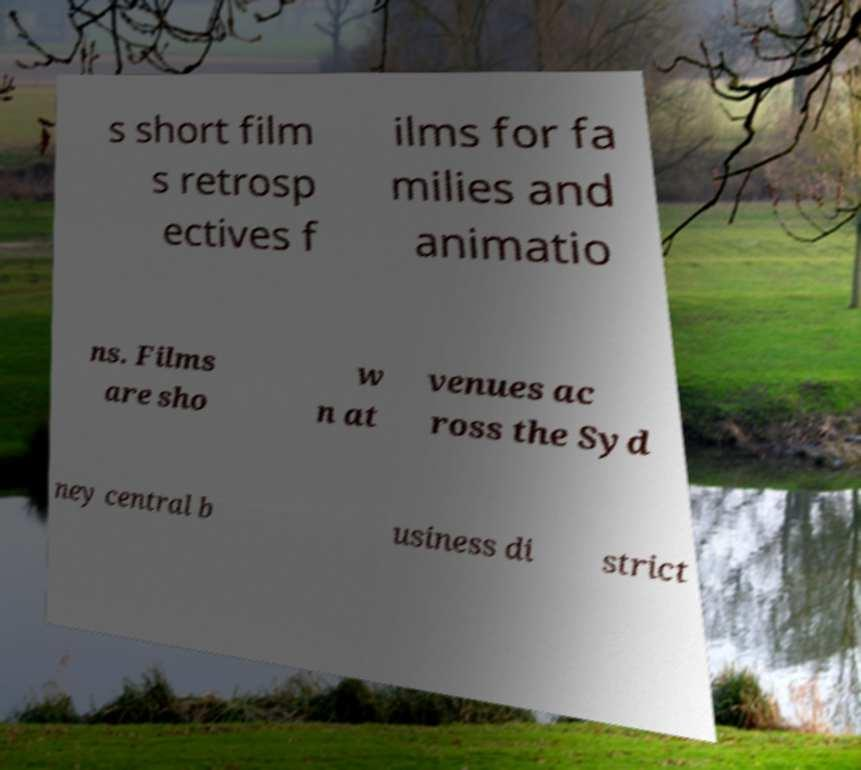Can you accurately transcribe the text from the provided image for me? s short film s retrosp ectives f ilms for fa milies and animatio ns. Films are sho w n at venues ac ross the Syd ney central b usiness di strict 